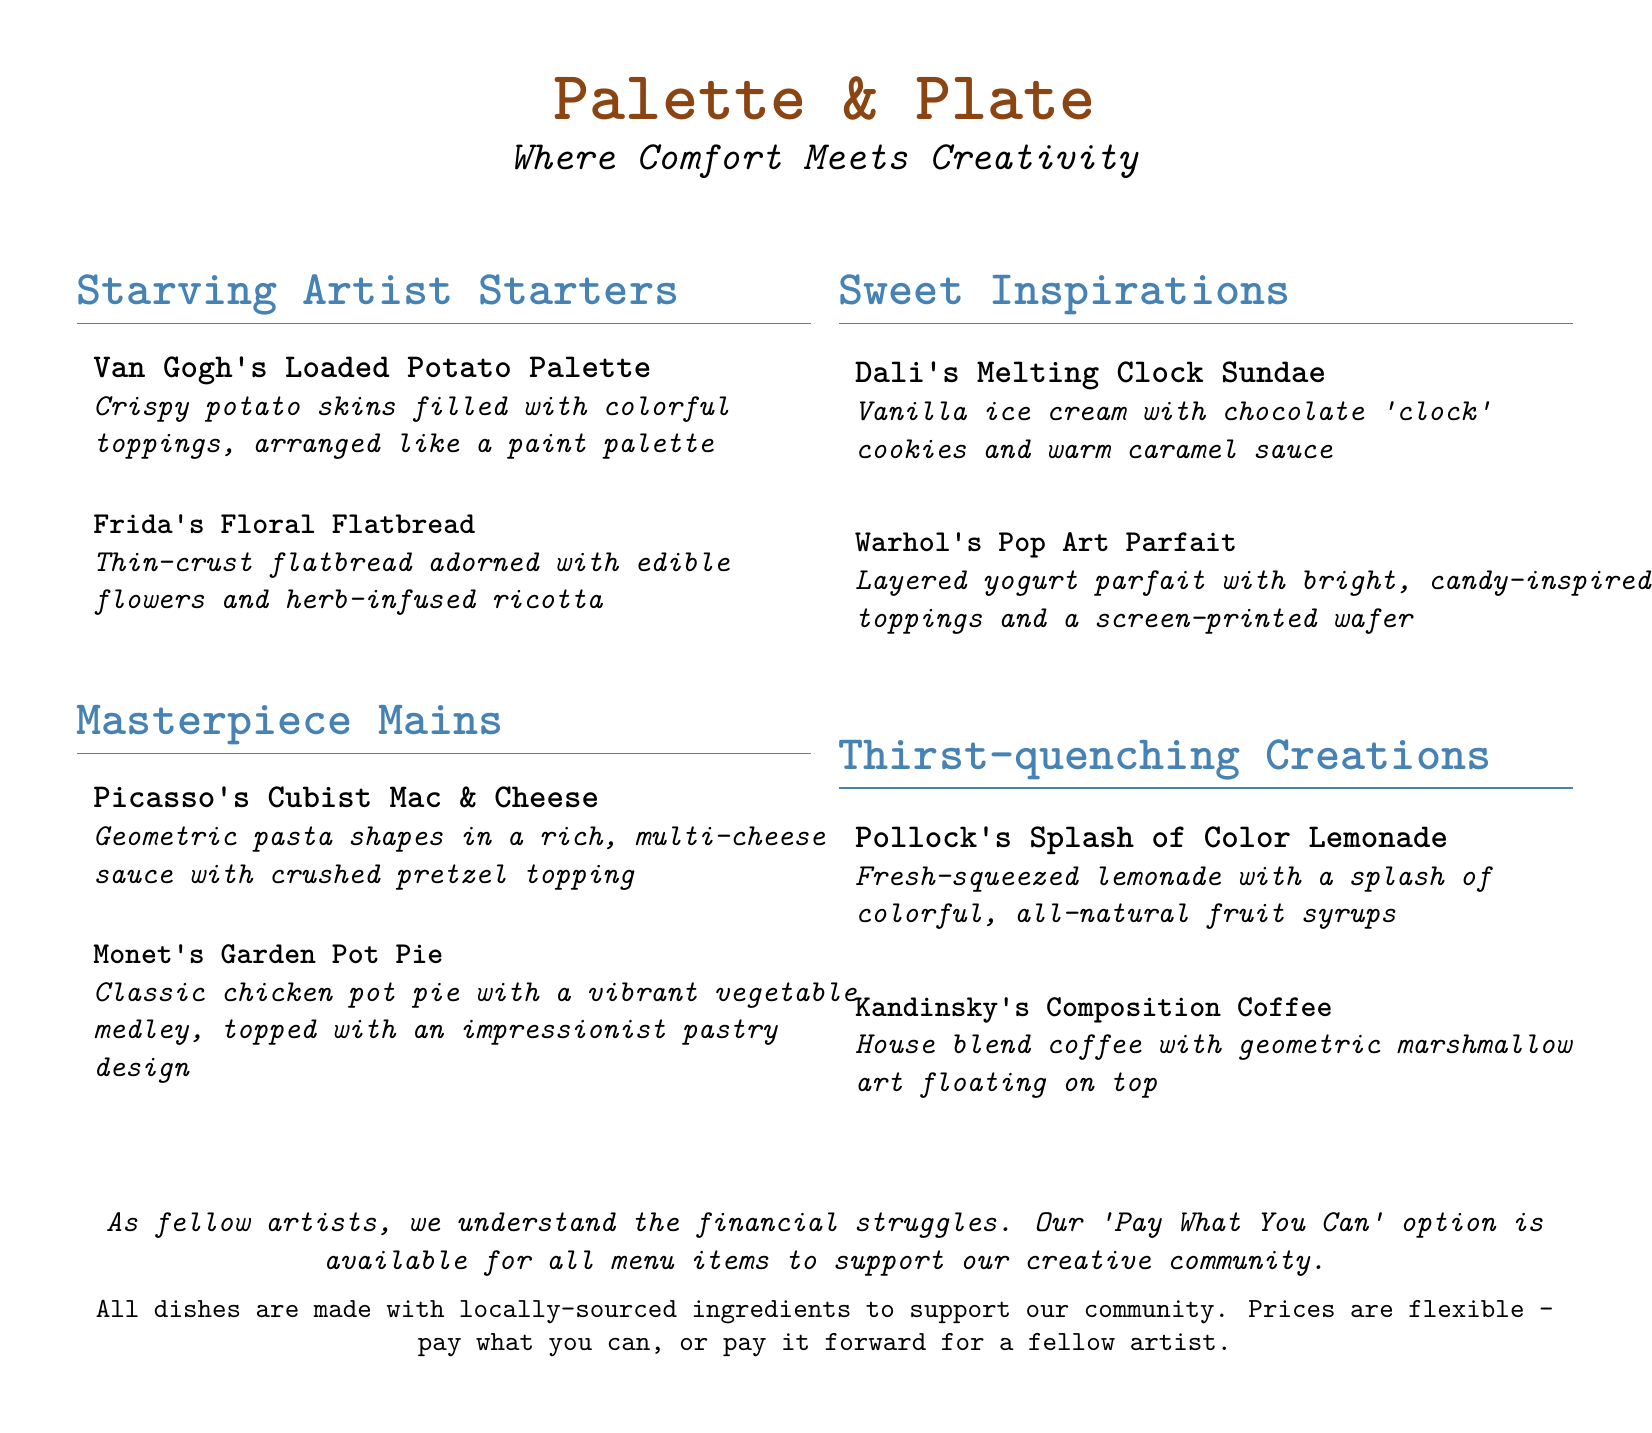What is the name of the restaurant? The restaurant is titled at the top of the document as "Palette & Plate."
Answer: Palette & Plate What is the theme of the restaurant? The theme is described under the title as "Where Comfort Meets Creativity."
Answer: Where Comfort Meets Creativity What is one starter listed on the menu? The menu includes a variety of items; one example is "Van Gogh's Loaded Potato Palette."
Answer: Van Gogh's Loaded Potato Palette How many main dishes are featured in the menu? There are two main dishes listed under "Masterpiece Mains."
Answer: 2 What is the 'Pay What You Can' option available for? The 'Pay What You Can' option is available to support the struggling artistic community.
Answer: Struggling artists What kind of desserts are included in the menu? The desserts are classified under "Sweet Inspirations."
Answer: Sweet Inspirations Which drink has a colorful name inspired by an artist? The drink "Pollock's Splash of Color Lemonade" features a colorful name.
Answer: Pollock's Splash of Color Lemonade Are the ingredients used locally sourced? The document mentions that all dishes are made with locally-sourced ingredients.
Answer: Yes What type of coffee is referenced in the menu? The coffee offered is referred to as "Kandinsky's Composition Coffee."
Answer: Kandinsky's Composition Coffee 